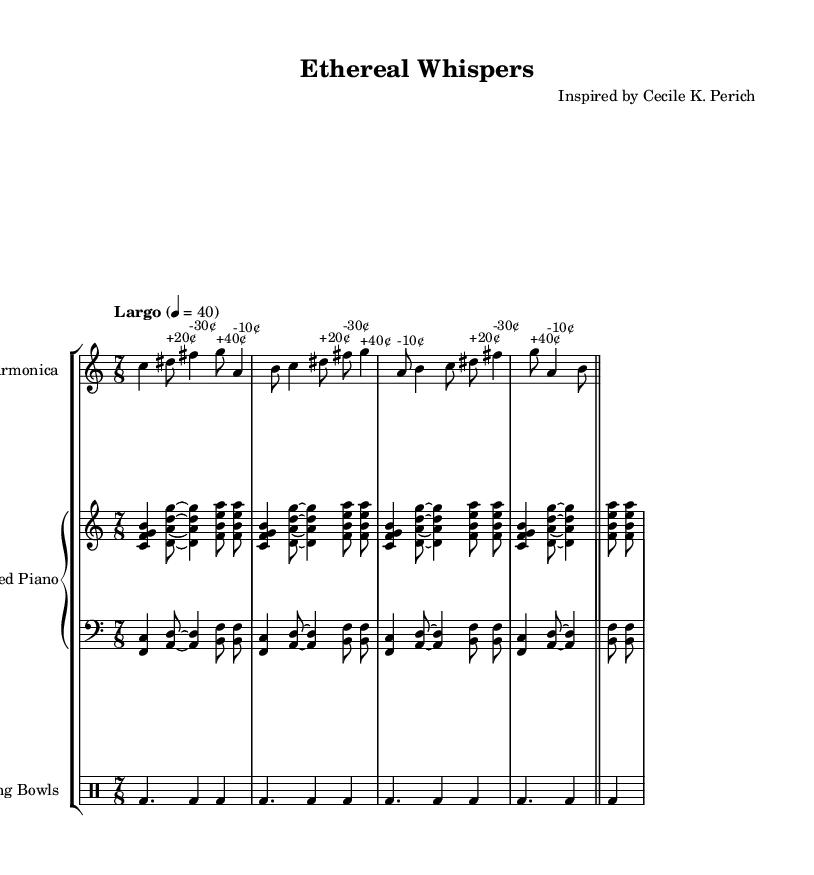What is the time signature of this music? The time signature indicates that the piece is in 7/8, which means there are seven eighth notes in each measure. The indication is found at the beginning of the score.
Answer: 7/8 What is the tempo marking for this piece? The tempo marking indicates a "Largo" tempo, which is a slow tempo, and the specific metronome marking provided is quarter note equals 40. This is usually placed at the beginning of the music.
Answer: Largo, 4 = 40 How many instruments are featured in this score? The score includes three distinct instrumental parts: the Glass Harmonica, Prepared Piano (with two staves), and Tibetan Singing Bowls. By counting the different instrument parts listed, we find three.
Answer: Three What is the range of the glass harmonica part? By analyzing the written pitch for the glass harmonica part, the notes range from C4 to G6. The clef indicates a treble clef, and examining the notes confirms the highest and lowest pitches in that part to be G6 and C4, respectively.
Answer: C4 to G6 What kind of techniques are used in the prepared piano sections? The prepared piano sections utilize extended techniques, such as playing specific clusters and possibly utilizing materials placed on or between the piano strings to achieve altered timbres. This reading comes from the presence of extended chords and various voicings in the piano parts.
Answer: Extended techniques Which measure has the most dense rhythmic activity in the Tibetan bowls? Upon reviewing the rhythmic pattern in the Tibetan bowls part, each measure consists of three bass drum hits; therefore, each measure is rhythmically consistent, showing no particular measure with greater density.
Answer: None 